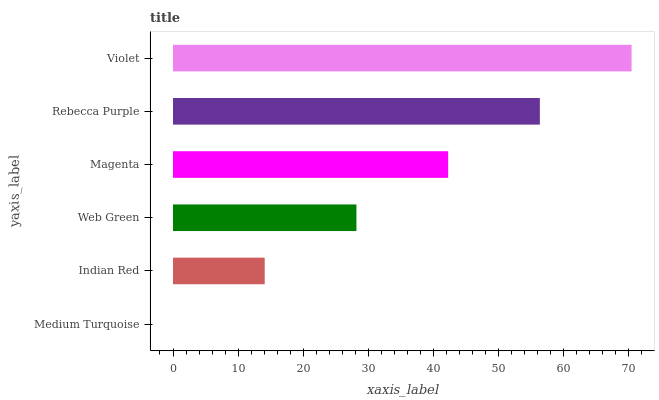Is Medium Turquoise the minimum?
Answer yes or no. Yes. Is Violet the maximum?
Answer yes or no. Yes. Is Indian Red the minimum?
Answer yes or no. No. Is Indian Red the maximum?
Answer yes or no. No. Is Indian Red greater than Medium Turquoise?
Answer yes or no. Yes. Is Medium Turquoise less than Indian Red?
Answer yes or no. Yes. Is Medium Turquoise greater than Indian Red?
Answer yes or no. No. Is Indian Red less than Medium Turquoise?
Answer yes or no. No. Is Magenta the high median?
Answer yes or no. Yes. Is Web Green the low median?
Answer yes or no. Yes. Is Indian Red the high median?
Answer yes or no. No. Is Violet the low median?
Answer yes or no. No. 